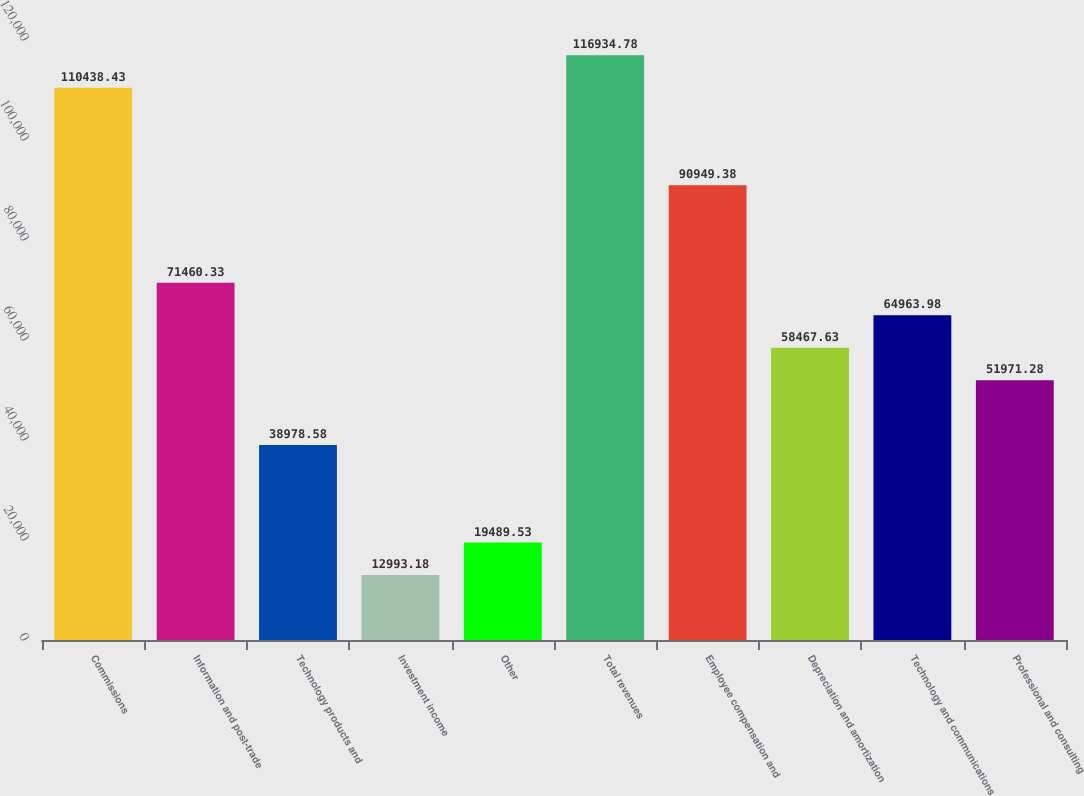Convert chart. <chart><loc_0><loc_0><loc_500><loc_500><bar_chart><fcel>Commissions<fcel>Information and post-trade<fcel>Technology products and<fcel>Investment income<fcel>Other<fcel>Total revenues<fcel>Employee compensation and<fcel>Depreciation and amortization<fcel>Technology and communications<fcel>Professional and consulting<nl><fcel>110438<fcel>71460.3<fcel>38978.6<fcel>12993.2<fcel>19489.5<fcel>116935<fcel>90949.4<fcel>58467.6<fcel>64964<fcel>51971.3<nl></chart> 